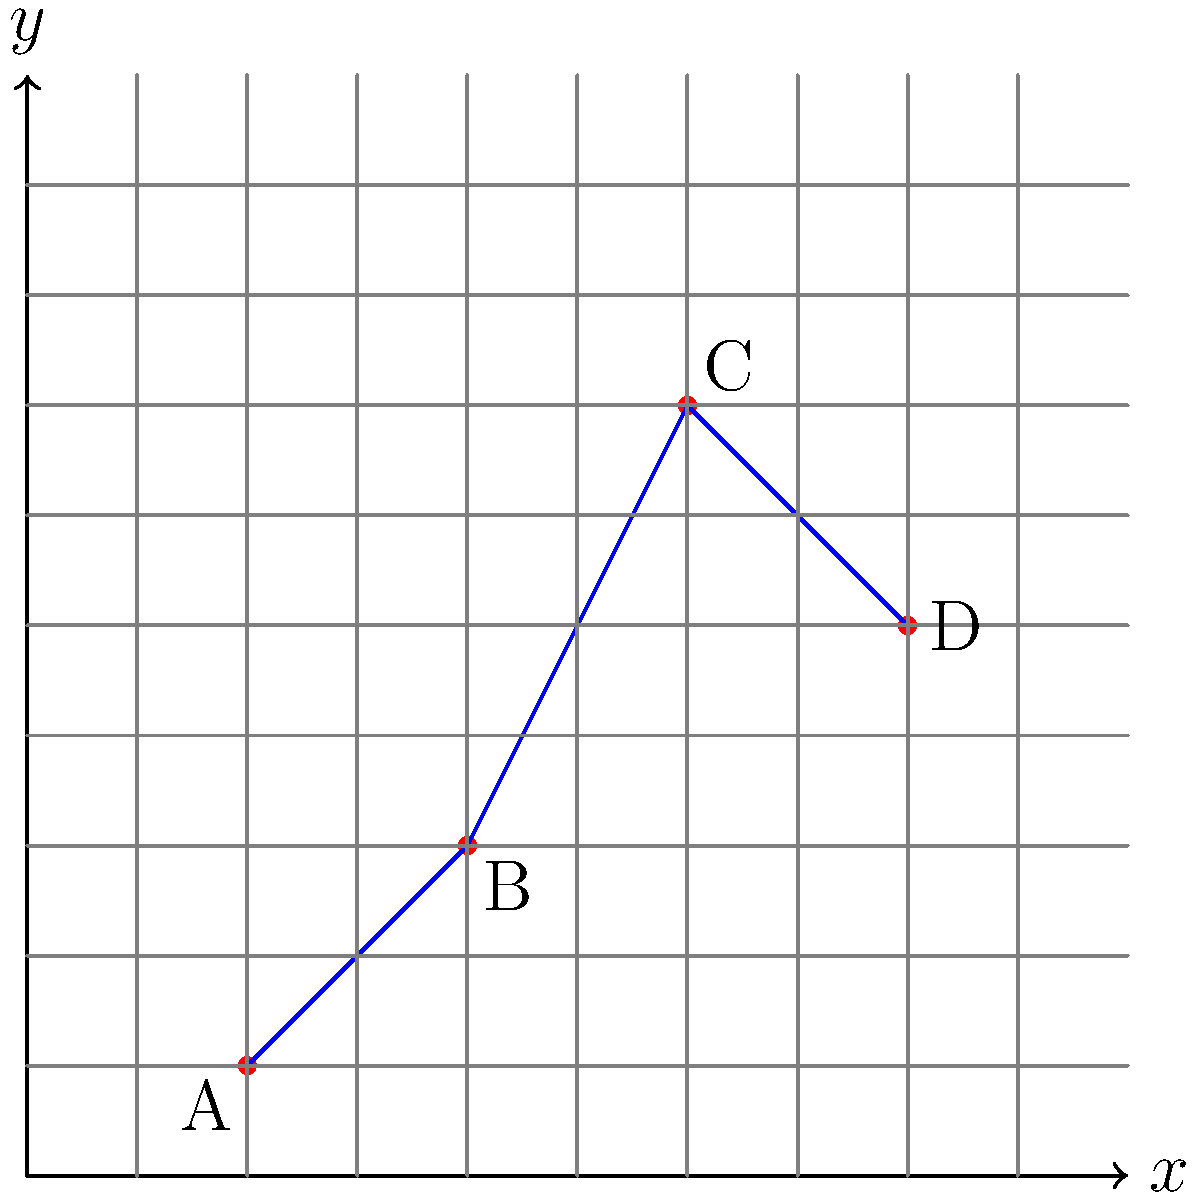As part of designing a new cross-country equestrian course, you need to plot the optimal path between four obstacles. The obstacles are located at points A(2,1), B(4,3), C(6,7), and D(8,5) on a coordinate grid where each unit represents 100 meters. Calculate the total distance of the course path from point A to point D, passing through points B and C in that order. Round your answer to the nearest meter. To solve this problem, we'll follow these steps:

1) First, we need to calculate the distance between each consecutive pair of points using the distance formula:
   $d = \sqrt{(x_2-x_1)^2 + (y_2-y_1)^2}$

2) Let's calculate each segment:

   AB: $d_{AB} = \sqrt{(4-2)^2 + (3-1)^2} = \sqrt{4 + 4} = \sqrt{8} = 2\sqrt{2}$
   
   BC: $d_{BC} = \sqrt{(6-4)^2 + (7-3)^2} = \sqrt{4 + 16} = \sqrt{20} = 2\sqrt{5}$
   
   CD: $d_{CD} = \sqrt{(8-6)^2 + (5-7)^2} = \sqrt{4 + 4} = \sqrt{8} = 2\sqrt{2}$

3) Now, we sum these distances:
   Total distance = $d_{AB} + d_{BC} + d_{CD} = 2\sqrt{2} + 2\sqrt{5} + 2\sqrt{2}$

4) Simplify: $4\sqrt{2} + 2\sqrt{5}$

5) Convert to decimal:
   $4\sqrt{2} \approx 5.6569$
   $2\sqrt{5} \approx 4.4721$
   Sum: $10.1290$

6) Multiply by 100 (since each unit is 100 meters):
   $10.1290 * 100 = 1012.90$ meters

7) Round to the nearest meter: 1013 meters
Answer: 1013 meters 